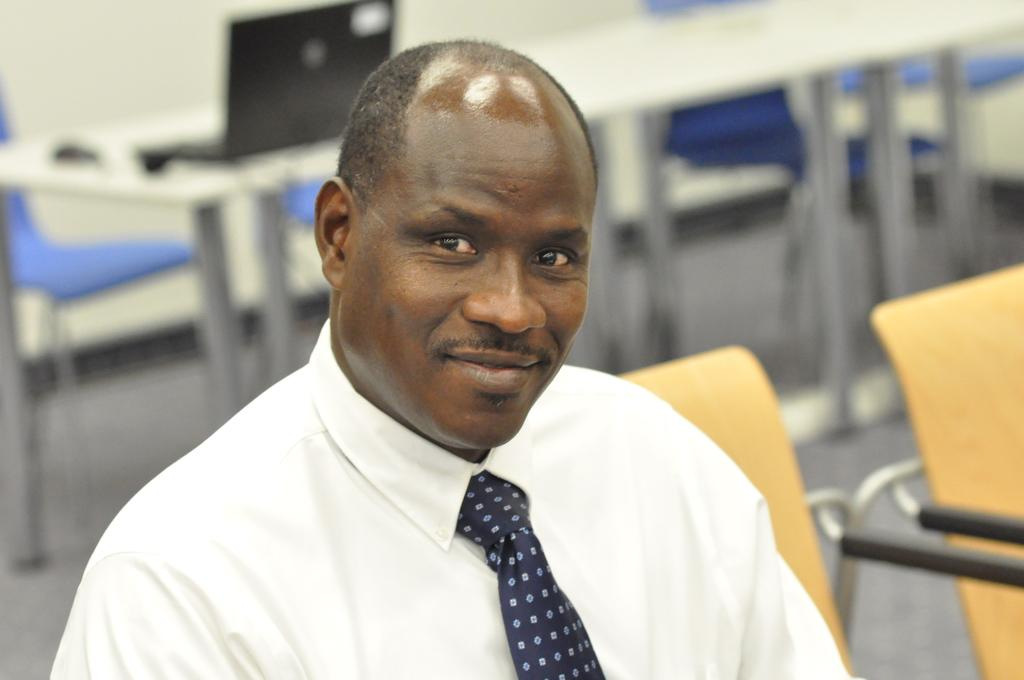What is the main subject of the image? There is a person in the image. What is the person's facial expression? The person is smiling. Can you describe the background of the image? The background of the image is blurry. What type of wool is being used to sing a song in the image? There is no wool or singing present in the image; it features a person smiling with a blurry background. 